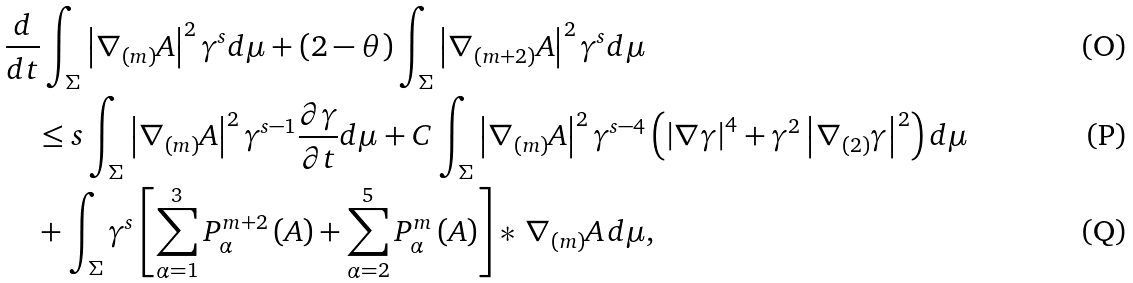<formula> <loc_0><loc_0><loc_500><loc_500>& \frac { d } { d t } \int _ { \Sigma } \left | \nabla _ { ( m ) } A \right | ^ { 2 } \gamma ^ { s } d \mu + \left ( 2 - \theta \right ) \int _ { \Sigma } \left | \nabla _ { ( m + 2 ) } A \right | ^ { 2 } \gamma ^ { s } d \mu \\ & \quad \leq s \int _ { \Sigma } \left | \nabla _ { ( m ) } A \right | ^ { 2 } \gamma ^ { s - 1 } \frac { \partial \gamma } { \partial t } d \mu + C \int _ { \Sigma } \left | \nabla _ { ( m ) } A \right | ^ { 2 } \gamma ^ { s - 4 } \left ( \left | \nabla \gamma \right | ^ { 4 } + \gamma ^ { 2 } \left | \nabla _ { ( 2 ) } \gamma \right | ^ { 2 } \right ) d \mu \\ & \quad + \int _ { \Sigma } \gamma ^ { s } \left [ \sum _ { \alpha = 1 } ^ { 3 } P _ { \alpha } ^ { m + 2 } \left ( A \right ) + \sum _ { \alpha = 2 } ^ { 5 } P _ { \alpha } ^ { m } \left ( A \right ) \right ] * \, \nabla _ { ( m ) } A \, d \mu ,</formula> 